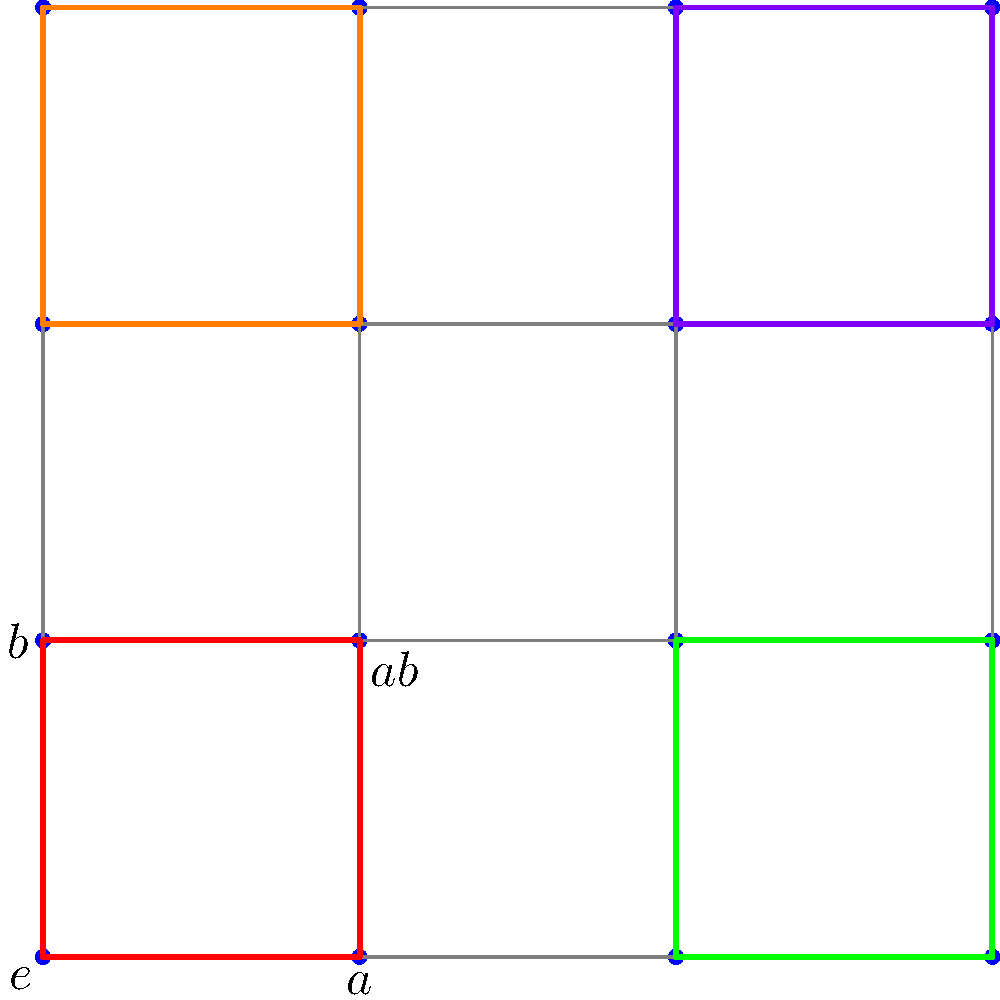In this 4x4 grid representing a group $G$ of order 16, the elements $e$ (identity), $a$, $b$, and $ab$ are labeled. The colored squares represent left cosets of a subgroup $H$. If the red square represents $H$ itself, what is the order of $H$, and how many distinct left cosets of $H$ are there in $G$? Let's approach this step-by-step:

1) First, we need to understand what the colored squares represent. Each colored square is a left coset of the subgroup $H$.

2) The red square represents $H$ itself. We can see that it contains 4 elements: $e$, $a$, $b$, and $ab$.

3) The order of a subgroup is the number of elements it contains. So, the order of $H$ is 4.

4) Now, let's count the number of distinct colored squares:
   - Red square (representing $H$)
   - Green square
   - Orange square
   - Purple square

5) Each of these colored squares represents a distinct left coset of $H$ in $G$.

6) We can see that there are 4 distinct colored squares, which means there are 4 distinct left cosets of $H$ in $G$.

7) This aligns with Lagrange's theorem, which states that the number of left cosets of a subgroup $H$ in a group $G$ is equal to the index of $H$ in $G$, given by $[G:H] = |G|/|H| = 16/4 = 4$.
Answer: Order of $H$: 4; Number of distinct left cosets: 4 